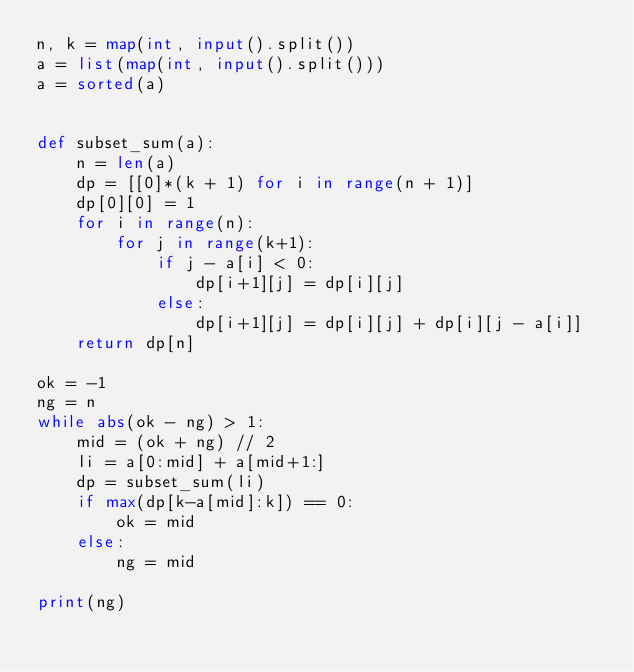<code> <loc_0><loc_0><loc_500><loc_500><_Python_>n, k = map(int, input().split())
a = list(map(int, input().split()))
a = sorted(a)


def subset_sum(a):
    n = len(a)
    dp = [[0]*(k + 1) for i in range(n + 1)]
    dp[0][0] = 1
    for i in range(n):
        for j in range(k+1):
            if j - a[i] < 0:
                dp[i+1][j] = dp[i][j]
            else:
                dp[i+1][j] = dp[i][j] + dp[i][j - a[i]]
    return dp[n]
  
ok = -1
ng = n
while abs(ok - ng) > 1:
    mid = (ok + ng) // 2
    li = a[0:mid] + a[mid+1:]
    dp = subset_sum(li)
    if max(dp[k-a[mid]:k]) == 0:
        ok = mid
    else:
        ng = mid
        
print(ng)</code> 